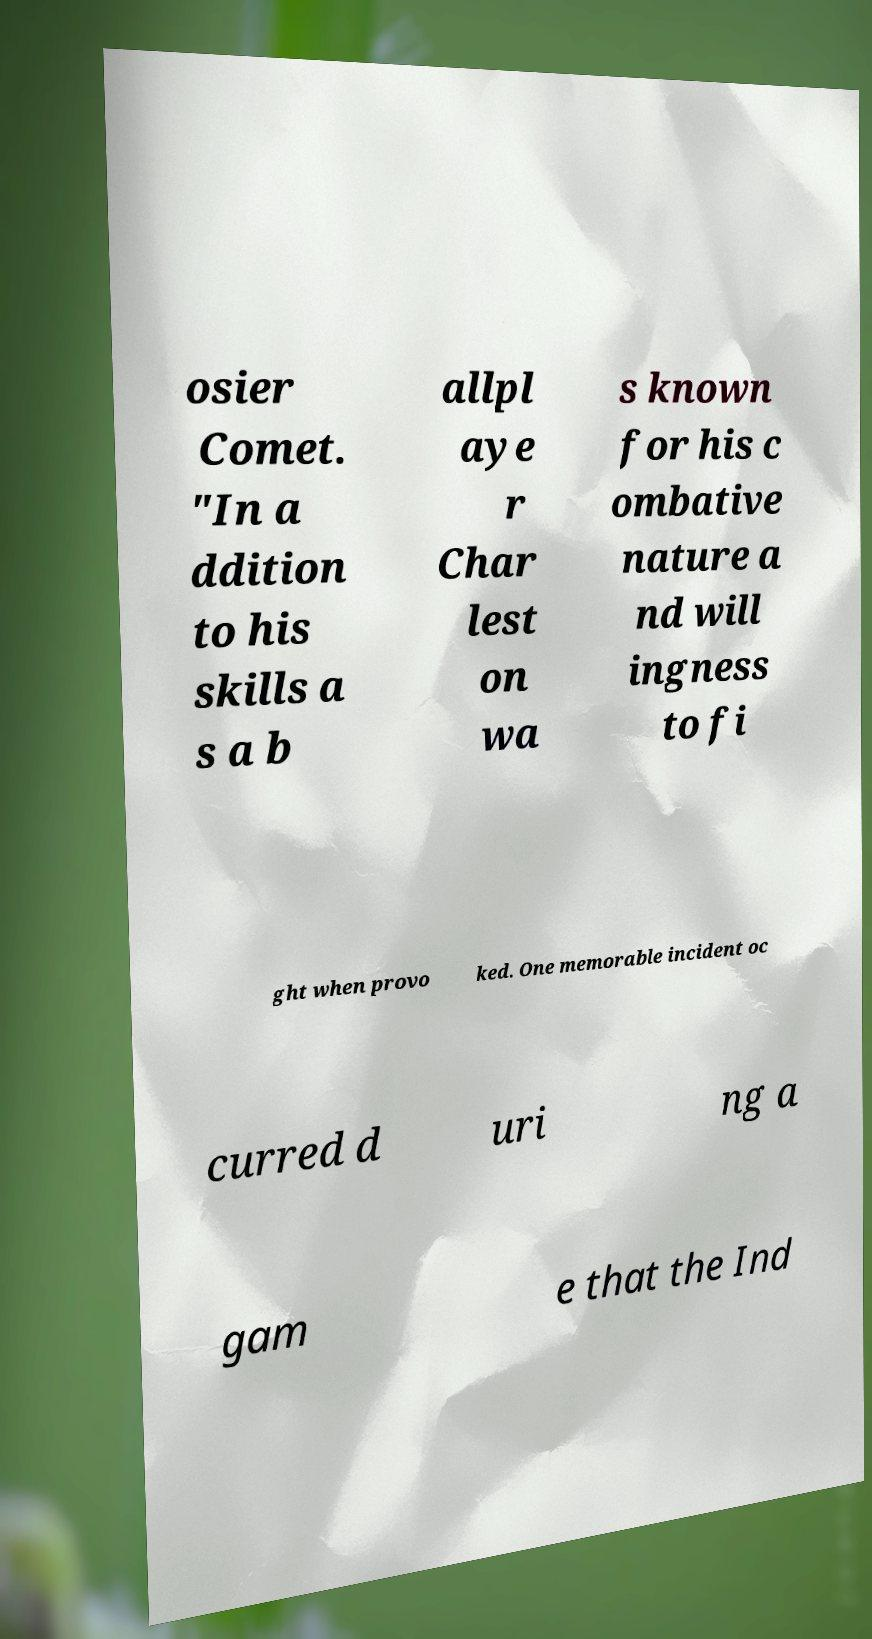What messages or text are displayed in this image? I need them in a readable, typed format. osier Comet. "In a ddition to his skills a s a b allpl aye r Char lest on wa s known for his c ombative nature a nd will ingness to fi ght when provo ked. One memorable incident oc curred d uri ng a gam e that the Ind 